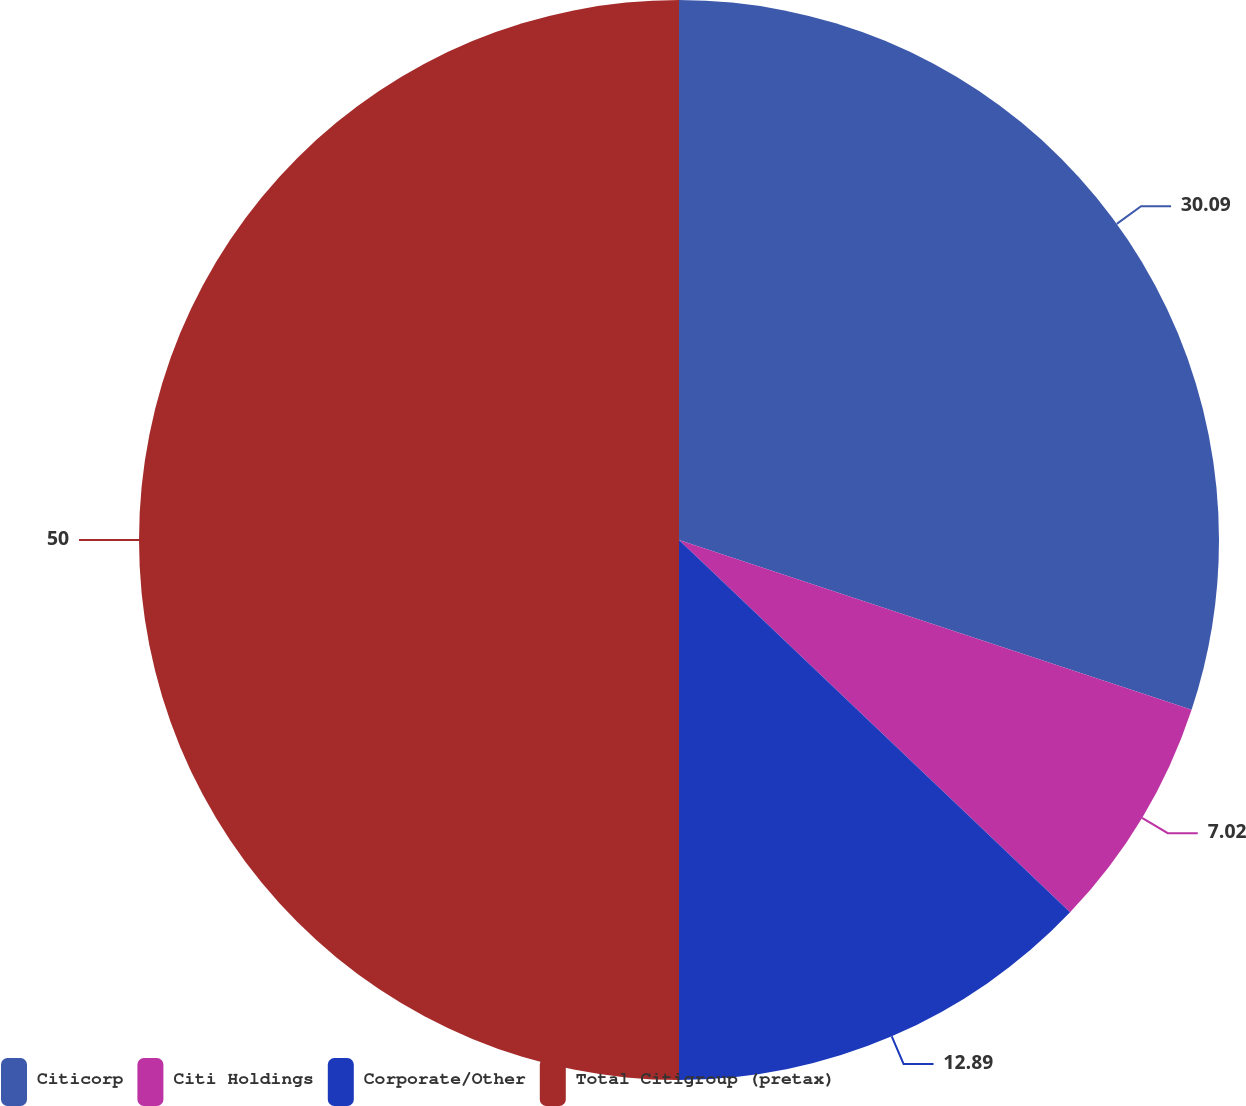Convert chart. <chart><loc_0><loc_0><loc_500><loc_500><pie_chart><fcel>Citicorp<fcel>Citi Holdings<fcel>Corporate/Other<fcel>Total Citigroup (pretax)<nl><fcel>30.09%<fcel>7.02%<fcel>12.89%<fcel>50.0%<nl></chart> 